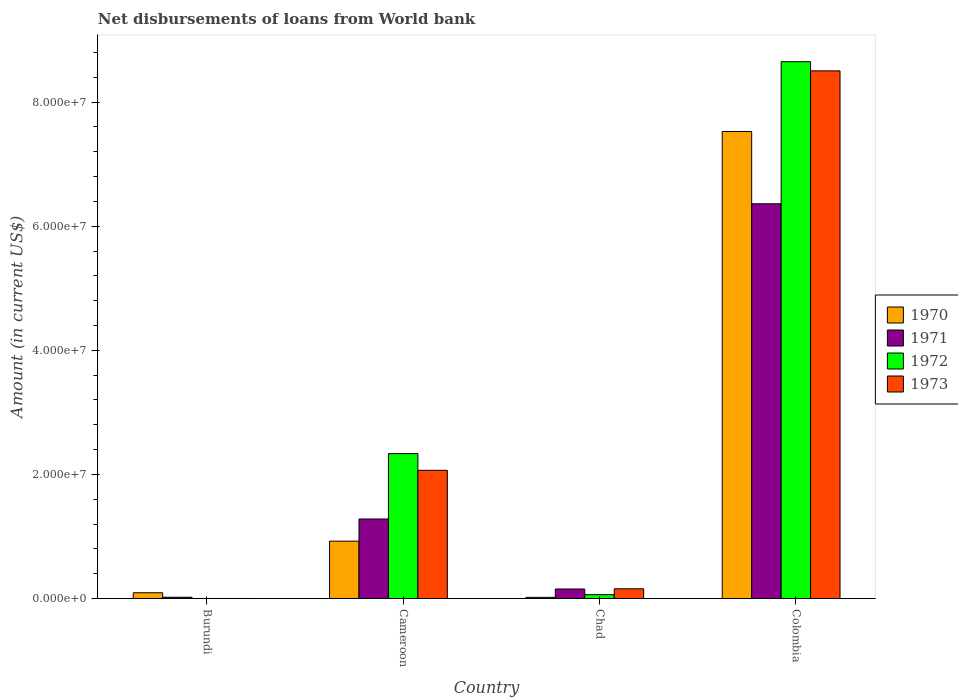Are the number of bars on each tick of the X-axis equal?
Provide a succinct answer. No. How many bars are there on the 3rd tick from the right?
Offer a very short reply. 4. What is the label of the 2nd group of bars from the left?
Your answer should be compact. Cameroon. What is the amount of loan disbursed from World Bank in 1970 in Colombia?
Offer a very short reply. 7.53e+07. Across all countries, what is the maximum amount of loan disbursed from World Bank in 1970?
Offer a terse response. 7.53e+07. Across all countries, what is the minimum amount of loan disbursed from World Bank in 1971?
Give a very brief answer. 2.01e+05. In which country was the amount of loan disbursed from World Bank in 1972 maximum?
Keep it short and to the point. Colombia. What is the total amount of loan disbursed from World Bank in 1971 in the graph?
Give a very brief answer. 7.82e+07. What is the difference between the amount of loan disbursed from World Bank in 1973 in Chad and that in Colombia?
Make the answer very short. -8.35e+07. What is the difference between the amount of loan disbursed from World Bank in 1971 in Burundi and the amount of loan disbursed from World Bank in 1972 in Cameroon?
Provide a succinct answer. -2.31e+07. What is the average amount of loan disbursed from World Bank in 1973 per country?
Your response must be concise. 2.68e+07. What is the difference between the amount of loan disbursed from World Bank of/in 1973 and amount of loan disbursed from World Bank of/in 1971 in Colombia?
Provide a short and direct response. 2.14e+07. In how many countries, is the amount of loan disbursed from World Bank in 1971 greater than 12000000 US$?
Make the answer very short. 2. What is the ratio of the amount of loan disbursed from World Bank in 1970 in Cameroon to that in Chad?
Your answer should be compact. 49.67. What is the difference between the highest and the second highest amount of loan disbursed from World Bank in 1972?
Your answer should be very brief. 6.32e+07. What is the difference between the highest and the lowest amount of loan disbursed from World Bank in 1972?
Provide a succinct answer. 8.65e+07. In how many countries, is the amount of loan disbursed from World Bank in 1970 greater than the average amount of loan disbursed from World Bank in 1970 taken over all countries?
Provide a succinct answer. 1. Is the sum of the amount of loan disbursed from World Bank in 1971 in Burundi and Colombia greater than the maximum amount of loan disbursed from World Bank in 1970 across all countries?
Make the answer very short. No. How many bars are there?
Your answer should be compact. 14. How many countries are there in the graph?
Ensure brevity in your answer.  4. Are the values on the major ticks of Y-axis written in scientific E-notation?
Offer a very short reply. Yes. Does the graph contain any zero values?
Ensure brevity in your answer.  Yes. Where does the legend appear in the graph?
Your response must be concise. Center right. How are the legend labels stacked?
Your answer should be compact. Vertical. What is the title of the graph?
Offer a very short reply. Net disbursements of loans from World bank. What is the label or title of the Y-axis?
Make the answer very short. Amount (in current US$). What is the Amount (in current US$) of 1970 in Burundi?
Your answer should be very brief. 9.23e+05. What is the Amount (in current US$) in 1971 in Burundi?
Make the answer very short. 2.01e+05. What is the Amount (in current US$) in 1973 in Burundi?
Your response must be concise. 0. What is the Amount (in current US$) in 1970 in Cameroon?
Offer a terse response. 9.24e+06. What is the Amount (in current US$) of 1971 in Cameroon?
Your answer should be compact. 1.28e+07. What is the Amount (in current US$) in 1972 in Cameroon?
Keep it short and to the point. 2.33e+07. What is the Amount (in current US$) in 1973 in Cameroon?
Give a very brief answer. 2.07e+07. What is the Amount (in current US$) in 1970 in Chad?
Provide a short and direct response. 1.86e+05. What is the Amount (in current US$) in 1971 in Chad?
Give a very brief answer. 1.53e+06. What is the Amount (in current US$) of 1972 in Chad?
Your answer should be compact. 6.17e+05. What is the Amount (in current US$) of 1973 in Chad?
Provide a short and direct response. 1.56e+06. What is the Amount (in current US$) of 1970 in Colombia?
Make the answer very short. 7.53e+07. What is the Amount (in current US$) of 1971 in Colombia?
Offer a very short reply. 6.36e+07. What is the Amount (in current US$) in 1972 in Colombia?
Your response must be concise. 8.65e+07. What is the Amount (in current US$) in 1973 in Colombia?
Your answer should be compact. 8.50e+07. Across all countries, what is the maximum Amount (in current US$) in 1970?
Provide a short and direct response. 7.53e+07. Across all countries, what is the maximum Amount (in current US$) of 1971?
Give a very brief answer. 6.36e+07. Across all countries, what is the maximum Amount (in current US$) in 1972?
Your answer should be very brief. 8.65e+07. Across all countries, what is the maximum Amount (in current US$) of 1973?
Ensure brevity in your answer.  8.50e+07. Across all countries, what is the minimum Amount (in current US$) of 1970?
Provide a short and direct response. 1.86e+05. Across all countries, what is the minimum Amount (in current US$) in 1971?
Provide a succinct answer. 2.01e+05. What is the total Amount (in current US$) in 1970 in the graph?
Your response must be concise. 8.56e+07. What is the total Amount (in current US$) in 1971 in the graph?
Offer a very short reply. 7.82e+07. What is the total Amount (in current US$) of 1972 in the graph?
Provide a short and direct response. 1.10e+08. What is the total Amount (in current US$) in 1973 in the graph?
Keep it short and to the point. 1.07e+08. What is the difference between the Amount (in current US$) in 1970 in Burundi and that in Cameroon?
Provide a short and direct response. -8.32e+06. What is the difference between the Amount (in current US$) of 1971 in Burundi and that in Cameroon?
Your answer should be compact. -1.26e+07. What is the difference between the Amount (in current US$) of 1970 in Burundi and that in Chad?
Your answer should be compact. 7.37e+05. What is the difference between the Amount (in current US$) in 1971 in Burundi and that in Chad?
Offer a very short reply. -1.33e+06. What is the difference between the Amount (in current US$) of 1970 in Burundi and that in Colombia?
Make the answer very short. -7.43e+07. What is the difference between the Amount (in current US$) in 1971 in Burundi and that in Colombia?
Your answer should be compact. -6.34e+07. What is the difference between the Amount (in current US$) in 1970 in Cameroon and that in Chad?
Your answer should be compact. 9.05e+06. What is the difference between the Amount (in current US$) in 1971 in Cameroon and that in Chad?
Offer a very short reply. 1.13e+07. What is the difference between the Amount (in current US$) in 1972 in Cameroon and that in Chad?
Offer a terse response. 2.27e+07. What is the difference between the Amount (in current US$) of 1973 in Cameroon and that in Chad?
Give a very brief answer. 1.91e+07. What is the difference between the Amount (in current US$) of 1970 in Cameroon and that in Colombia?
Provide a short and direct response. -6.60e+07. What is the difference between the Amount (in current US$) of 1971 in Cameroon and that in Colombia?
Your response must be concise. -5.08e+07. What is the difference between the Amount (in current US$) in 1972 in Cameroon and that in Colombia?
Make the answer very short. -6.32e+07. What is the difference between the Amount (in current US$) of 1973 in Cameroon and that in Colombia?
Ensure brevity in your answer.  -6.44e+07. What is the difference between the Amount (in current US$) in 1970 in Chad and that in Colombia?
Offer a very short reply. -7.51e+07. What is the difference between the Amount (in current US$) in 1971 in Chad and that in Colombia?
Keep it short and to the point. -6.21e+07. What is the difference between the Amount (in current US$) in 1972 in Chad and that in Colombia?
Provide a succinct answer. -8.59e+07. What is the difference between the Amount (in current US$) in 1973 in Chad and that in Colombia?
Offer a terse response. -8.35e+07. What is the difference between the Amount (in current US$) of 1970 in Burundi and the Amount (in current US$) of 1971 in Cameroon?
Ensure brevity in your answer.  -1.19e+07. What is the difference between the Amount (in current US$) in 1970 in Burundi and the Amount (in current US$) in 1972 in Cameroon?
Keep it short and to the point. -2.24e+07. What is the difference between the Amount (in current US$) in 1970 in Burundi and the Amount (in current US$) in 1973 in Cameroon?
Ensure brevity in your answer.  -1.97e+07. What is the difference between the Amount (in current US$) of 1971 in Burundi and the Amount (in current US$) of 1972 in Cameroon?
Offer a very short reply. -2.31e+07. What is the difference between the Amount (in current US$) of 1971 in Burundi and the Amount (in current US$) of 1973 in Cameroon?
Make the answer very short. -2.05e+07. What is the difference between the Amount (in current US$) in 1970 in Burundi and the Amount (in current US$) in 1971 in Chad?
Keep it short and to the point. -6.07e+05. What is the difference between the Amount (in current US$) of 1970 in Burundi and the Amount (in current US$) of 1972 in Chad?
Offer a terse response. 3.06e+05. What is the difference between the Amount (in current US$) of 1970 in Burundi and the Amount (in current US$) of 1973 in Chad?
Make the answer very short. -6.37e+05. What is the difference between the Amount (in current US$) of 1971 in Burundi and the Amount (in current US$) of 1972 in Chad?
Your response must be concise. -4.16e+05. What is the difference between the Amount (in current US$) of 1971 in Burundi and the Amount (in current US$) of 1973 in Chad?
Offer a very short reply. -1.36e+06. What is the difference between the Amount (in current US$) of 1970 in Burundi and the Amount (in current US$) of 1971 in Colombia?
Make the answer very short. -6.27e+07. What is the difference between the Amount (in current US$) of 1970 in Burundi and the Amount (in current US$) of 1972 in Colombia?
Give a very brief answer. -8.56e+07. What is the difference between the Amount (in current US$) of 1970 in Burundi and the Amount (in current US$) of 1973 in Colombia?
Make the answer very short. -8.41e+07. What is the difference between the Amount (in current US$) of 1971 in Burundi and the Amount (in current US$) of 1972 in Colombia?
Your answer should be compact. -8.63e+07. What is the difference between the Amount (in current US$) in 1971 in Burundi and the Amount (in current US$) in 1973 in Colombia?
Your response must be concise. -8.48e+07. What is the difference between the Amount (in current US$) of 1970 in Cameroon and the Amount (in current US$) of 1971 in Chad?
Your answer should be compact. 7.71e+06. What is the difference between the Amount (in current US$) of 1970 in Cameroon and the Amount (in current US$) of 1972 in Chad?
Your answer should be compact. 8.62e+06. What is the difference between the Amount (in current US$) of 1970 in Cameroon and the Amount (in current US$) of 1973 in Chad?
Your answer should be compact. 7.68e+06. What is the difference between the Amount (in current US$) of 1971 in Cameroon and the Amount (in current US$) of 1972 in Chad?
Make the answer very short. 1.22e+07. What is the difference between the Amount (in current US$) in 1971 in Cameroon and the Amount (in current US$) in 1973 in Chad?
Provide a succinct answer. 1.13e+07. What is the difference between the Amount (in current US$) of 1972 in Cameroon and the Amount (in current US$) of 1973 in Chad?
Give a very brief answer. 2.18e+07. What is the difference between the Amount (in current US$) of 1970 in Cameroon and the Amount (in current US$) of 1971 in Colombia?
Your response must be concise. -5.44e+07. What is the difference between the Amount (in current US$) in 1970 in Cameroon and the Amount (in current US$) in 1972 in Colombia?
Give a very brief answer. -7.73e+07. What is the difference between the Amount (in current US$) of 1970 in Cameroon and the Amount (in current US$) of 1973 in Colombia?
Offer a very short reply. -7.58e+07. What is the difference between the Amount (in current US$) in 1971 in Cameroon and the Amount (in current US$) in 1972 in Colombia?
Your answer should be very brief. -7.37e+07. What is the difference between the Amount (in current US$) of 1971 in Cameroon and the Amount (in current US$) of 1973 in Colombia?
Your answer should be compact. -7.22e+07. What is the difference between the Amount (in current US$) of 1972 in Cameroon and the Amount (in current US$) of 1973 in Colombia?
Ensure brevity in your answer.  -6.17e+07. What is the difference between the Amount (in current US$) of 1970 in Chad and the Amount (in current US$) of 1971 in Colombia?
Ensure brevity in your answer.  -6.34e+07. What is the difference between the Amount (in current US$) in 1970 in Chad and the Amount (in current US$) in 1972 in Colombia?
Your response must be concise. -8.63e+07. What is the difference between the Amount (in current US$) in 1970 in Chad and the Amount (in current US$) in 1973 in Colombia?
Your answer should be very brief. -8.48e+07. What is the difference between the Amount (in current US$) in 1971 in Chad and the Amount (in current US$) in 1972 in Colombia?
Provide a succinct answer. -8.50e+07. What is the difference between the Amount (in current US$) of 1971 in Chad and the Amount (in current US$) of 1973 in Colombia?
Keep it short and to the point. -8.35e+07. What is the difference between the Amount (in current US$) of 1972 in Chad and the Amount (in current US$) of 1973 in Colombia?
Your response must be concise. -8.44e+07. What is the average Amount (in current US$) of 1970 per country?
Your answer should be very brief. 2.14e+07. What is the average Amount (in current US$) of 1971 per country?
Your response must be concise. 1.95e+07. What is the average Amount (in current US$) of 1972 per country?
Give a very brief answer. 2.76e+07. What is the average Amount (in current US$) of 1973 per country?
Your answer should be compact. 2.68e+07. What is the difference between the Amount (in current US$) in 1970 and Amount (in current US$) in 1971 in Burundi?
Provide a succinct answer. 7.22e+05. What is the difference between the Amount (in current US$) of 1970 and Amount (in current US$) of 1971 in Cameroon?
Keep it short and to the point. -3.57e+06. What is the difference between the Amount (in current US$) of 1970 and Amount (in current US$) of 1972 in Cameroon?
Provide a succinct answer. -1.41e+07. What is the difference between the Amount (in current US$) in 1970 and Amount (in current US$) in 1973 in Cameroon?
Offer a very short reply. -1.14e+07. What is the difference between the Amount (in current US$) in 1971 and Amount (in current US$) in 1972 in Cameroon?
Provide a succinct answer. -1.05e+07. What is the difference between the Amount (in current US$) in 1971 and Amount (in current US$) in 1973 in Cameroon?
Your answer should be very brief. -7.84e+06. What is the difference between the Amount (in current US$) of 1972 and Amount (in current US$) of 1973 in Cameroon?
Give a very brief answer. 2.69e+06. What is the difference between the Amount (in current US$) of 1970 and Amount (in current US$) of 1971 in Chad?
Offer a terse response. -1.34e+06. What is the difference between the Amount (in current US$) in 1970 and Amount (in current US$) in 1972 in Chad?
Provide a short and direct response. -4.31e+05. What is the difference between the Amount (in current US$) of 1970 and Amount (in current US$) of 1973 in Chad?
Your answer should be very brief. -1.37e+06. What is the difference between the Amount (in current US$) of 1971 and Amount (in current US$) of 1972 in Chad?
Make the answer very short. 9.13e+05. What is the difference between the Amount (in current US$) in 1972 and Amount (in current US$) in 1973 in Chad?
Offer a very short reply. -9.43e+05. What is the difference between the Amount (in current US$) in 1970 and Amount (in current US$) in 1971 in Colombia?
Your response must be concise. 1.16e+07. What is the difference between the Amount (in current US$) in 1970 and Amount (in current US$) in 1972 in Colombia?
Offer a very short reply. -1.12e+07. What is the difference between the Amount (in current US$) in 1970 and Amount (in current US$) in 1973 in Colombia?
Offer a terse response. -9.77e+06. What is the difference between the Amount (in current US$) of 1971 and Amount (in current US$) of 1972 in Colombia?
Ensure brevity in your answer.  -2.29e+07. What is the difference between the Amount (in current US$) of 1971 and Amount (in current US$) of 1973 in Colombia?
Your answer should be very brief. -2.14e+07. What is the difference between the Amount (in current US$) in 1972 and Amount (in current US$) in 1973 in Colombia?
Offer a terse response. 1.47e+06. What is the ratio of the Amount (in current US$) of 1970 in Burundi to that in Cameroon?
Offer a terse response. 0.1. What is the ratio of the Amount (in current US$) of 1971 in Burundi to that in Cameroon?
Your response must be concise. 0.02. What is the ratio of the Amount (in current US$) of 1970 in Burundi to that in Chad?
Offer a terse response. 4.96. What is the ratio of the Amount (in current US$) in 1971 in Burundi to that in Chad?
Give a very brief answer. 0.13. What is the ratio of the Amount (in current US$) in 1970 in Burundi to that in Colombia?
Offer a terse response. 0.01. What is the ratio of the Amount (in current US$) of 1971 in Burundi to that in Colombia?
Offer a terse response. 0. What is the ratio of the Amount (in current US$) in 1970 in Cameroon to that in Chad?
Ensure brevity in your answer.  49.67. What is the ratio of the Amount (in current US$) of 1971 in Cameroon to that in Chad?
Give a very brief answer. 8.37. What is the ratio of the Amount (in current US$) of 1972 in Cameroon to that in Chad?
Provide a succinct answer. 37.84. What is the ratio of the Amount (in current US$) of 1973 in Cameroon to that in Chad?
Your answer should be very brief. 13.24. What is the ratio of the Amount (in current US$) of 1970 in Cameroon to that in Colombia?
Offer a terse response. 0.12. What is the ratio of the Amount (in current US$) in 1971 in Cameroon to that in Colombia?
Offer a very short reply. 0.2. What is the ratio of the Amount (in current US$) in 1972 in Cameroon to that in Colombia?
Your answer should be compact. 0.27. What is the ratio of the Amount (in current US$) of 1973 in Cameroon to that in Colombia?
Your response must be concise. 0.24. What is the ratio of the Amount (in current US$) in 1970 in Chad to that in Colombia?
Your response must be concise. 0. What is the ratio of the Amount (in current US$) of 1971 in Chad to that in Colombia?
Ensure brevity in your answer.  0.02. What is the ratio of the Amount (in current US$) in 1972 in Chad to that in Colombia?
Give a very brief answer. 0.01. What is the ratio of the Amount (in current US$) of 1973 in Chad to that in Colombia?
Ensure brevity in your answer.  0.02. What is the difference between the highest and the second highest Amount (in current US$) in 1970?
Your response must be concise. 6.60e+07. What is the difference between the highest and the second highest Amount (in current US$) of 1971?
Keep it short and to the point. 5.08e+07. What is the difference between the highest and the second highest Amount (in current US$) of 1972?
Keep it short and to the point. 6.32e+07. What is the difference between the highest and the second highest Amount (in current US$) in 1973?
Make the answer very short. 6.44e+07. What is the difference between the highest and the lowest Amount (in current US$) in 1970?
Your response must be concise. 7.51e+07. What is the difference between the highest and the lowest Amount (in current US$) in 1971?
Make the answer very short. 6.34e+07. What is the difference between the highest and the lowest Amount (in current US$) of 1972?
Your answer should be very brief. 8.65e+07. What is the difference between the highest and the lowest Amount (in current US$) of 1973?
Make the answer very short. 8.50e+07. 